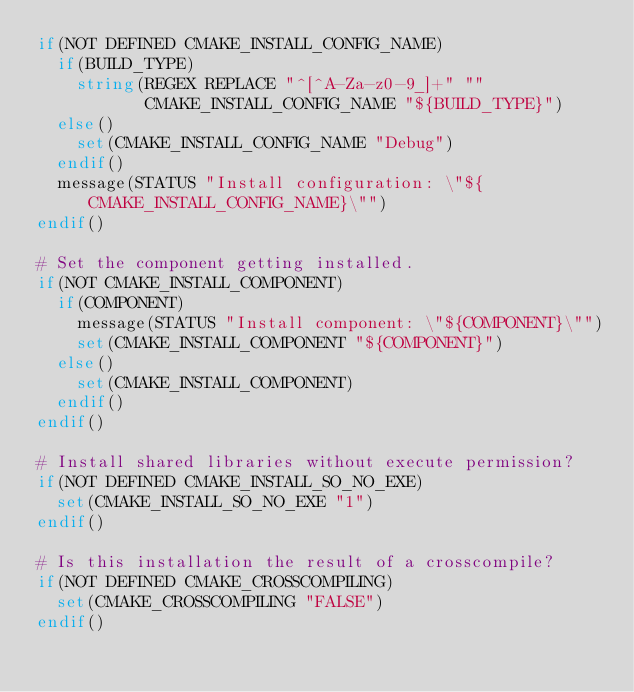Convert code to text. <code><loc_0><loc_0><loc_500><loc_500><_CMake_>if(NOT DEFINED CMAKE_INSTALL_CONFIG_NAME)
  if(BUILD_TYPE)
    string(REGEX REPLACE "^[^A-Za-z0-9_]+" ""
           CMAKE_INSTALL_CONFIG_NAME "${BUILD_TYPE}")
  else()
    set(CMAKE_INSTALL_CONFIG_NAME "Debug")
  endif()
  message(STATUS "Install configuration: \"${CMAKE_INSTALL_CONFIG_NAME}\"")
endif()

# Set the component getting installed.
if(NOT CMAKE_INSTALL_COMPONENT)
  if(COMPONENT)
    message(STATUS "Install component: \"${COMPONENT}\"")
    set(CMAKE_INSTALL_COMPONENT "${COMPONENT}")
  else()
    set(CMAKE_INSTALL_COMPONENT)
  endif()
endif()

# Install shared libraries without execute permission?
if(NOT DEFINED CMAKE_INSTALL_SO_NO_EXE)
  set(CMAKE_INSTALL_SO_NO_EXE "1")
endif()

# Is this installation the result of a crosscompile?
if(NOT DEFINED CMAKE_CROSSCOMPILING)
  set(CMAKE_CROSSCOMPILING "FALSE")
endif()

</code> 